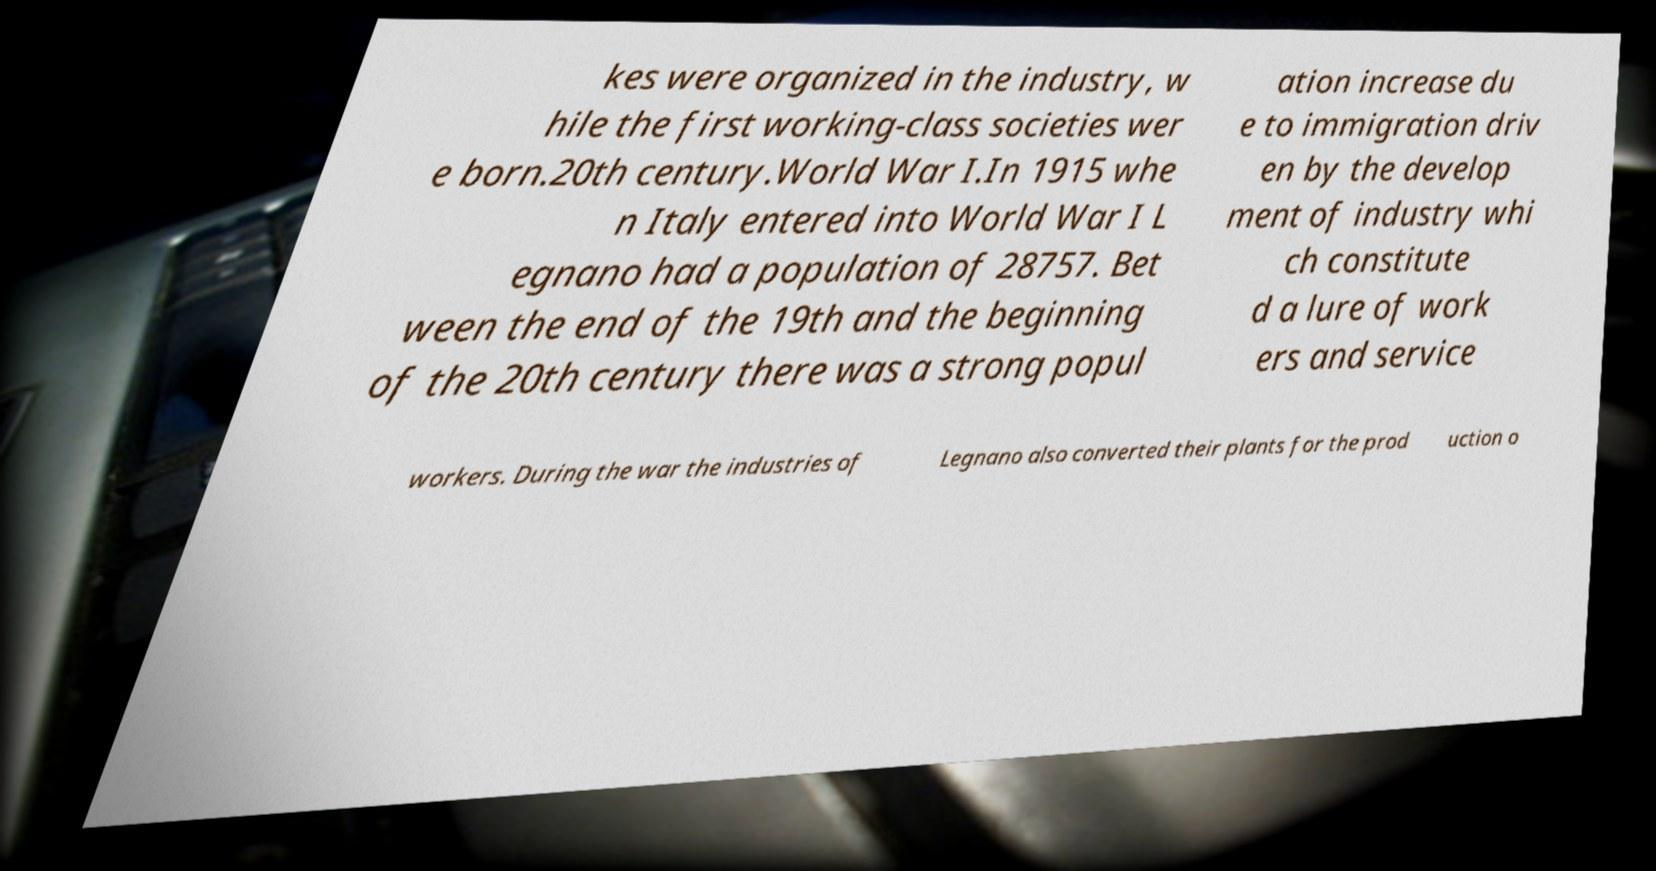Please identify and transcribe the text found in this image. kes were organized in the industry, w hile the first working-class societies wer e born.20th century.World War I.In 1915 whe n Italy entered into World War I L egnano had a population of 28757. Bet ween the end of the 19th and the beginning of the 20th century there was a strong popul ation increase du e to immigration driv en by the develop ment of industry whi ch constitute d a lure of work ers and service workers. During the war the industries of Legnano also converted their plants for the prod uction o 